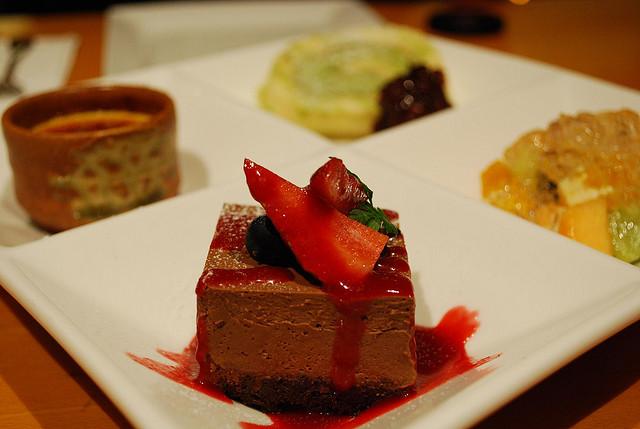What color is the plate?
Write a very short answer. White. Could this be dessert?
Quick response, please. Yes. What is on top of the strawberry?
Write a very short answer. Sauce. Why is this particular dessert located in the foreground?
Short answer required. Not sure. 